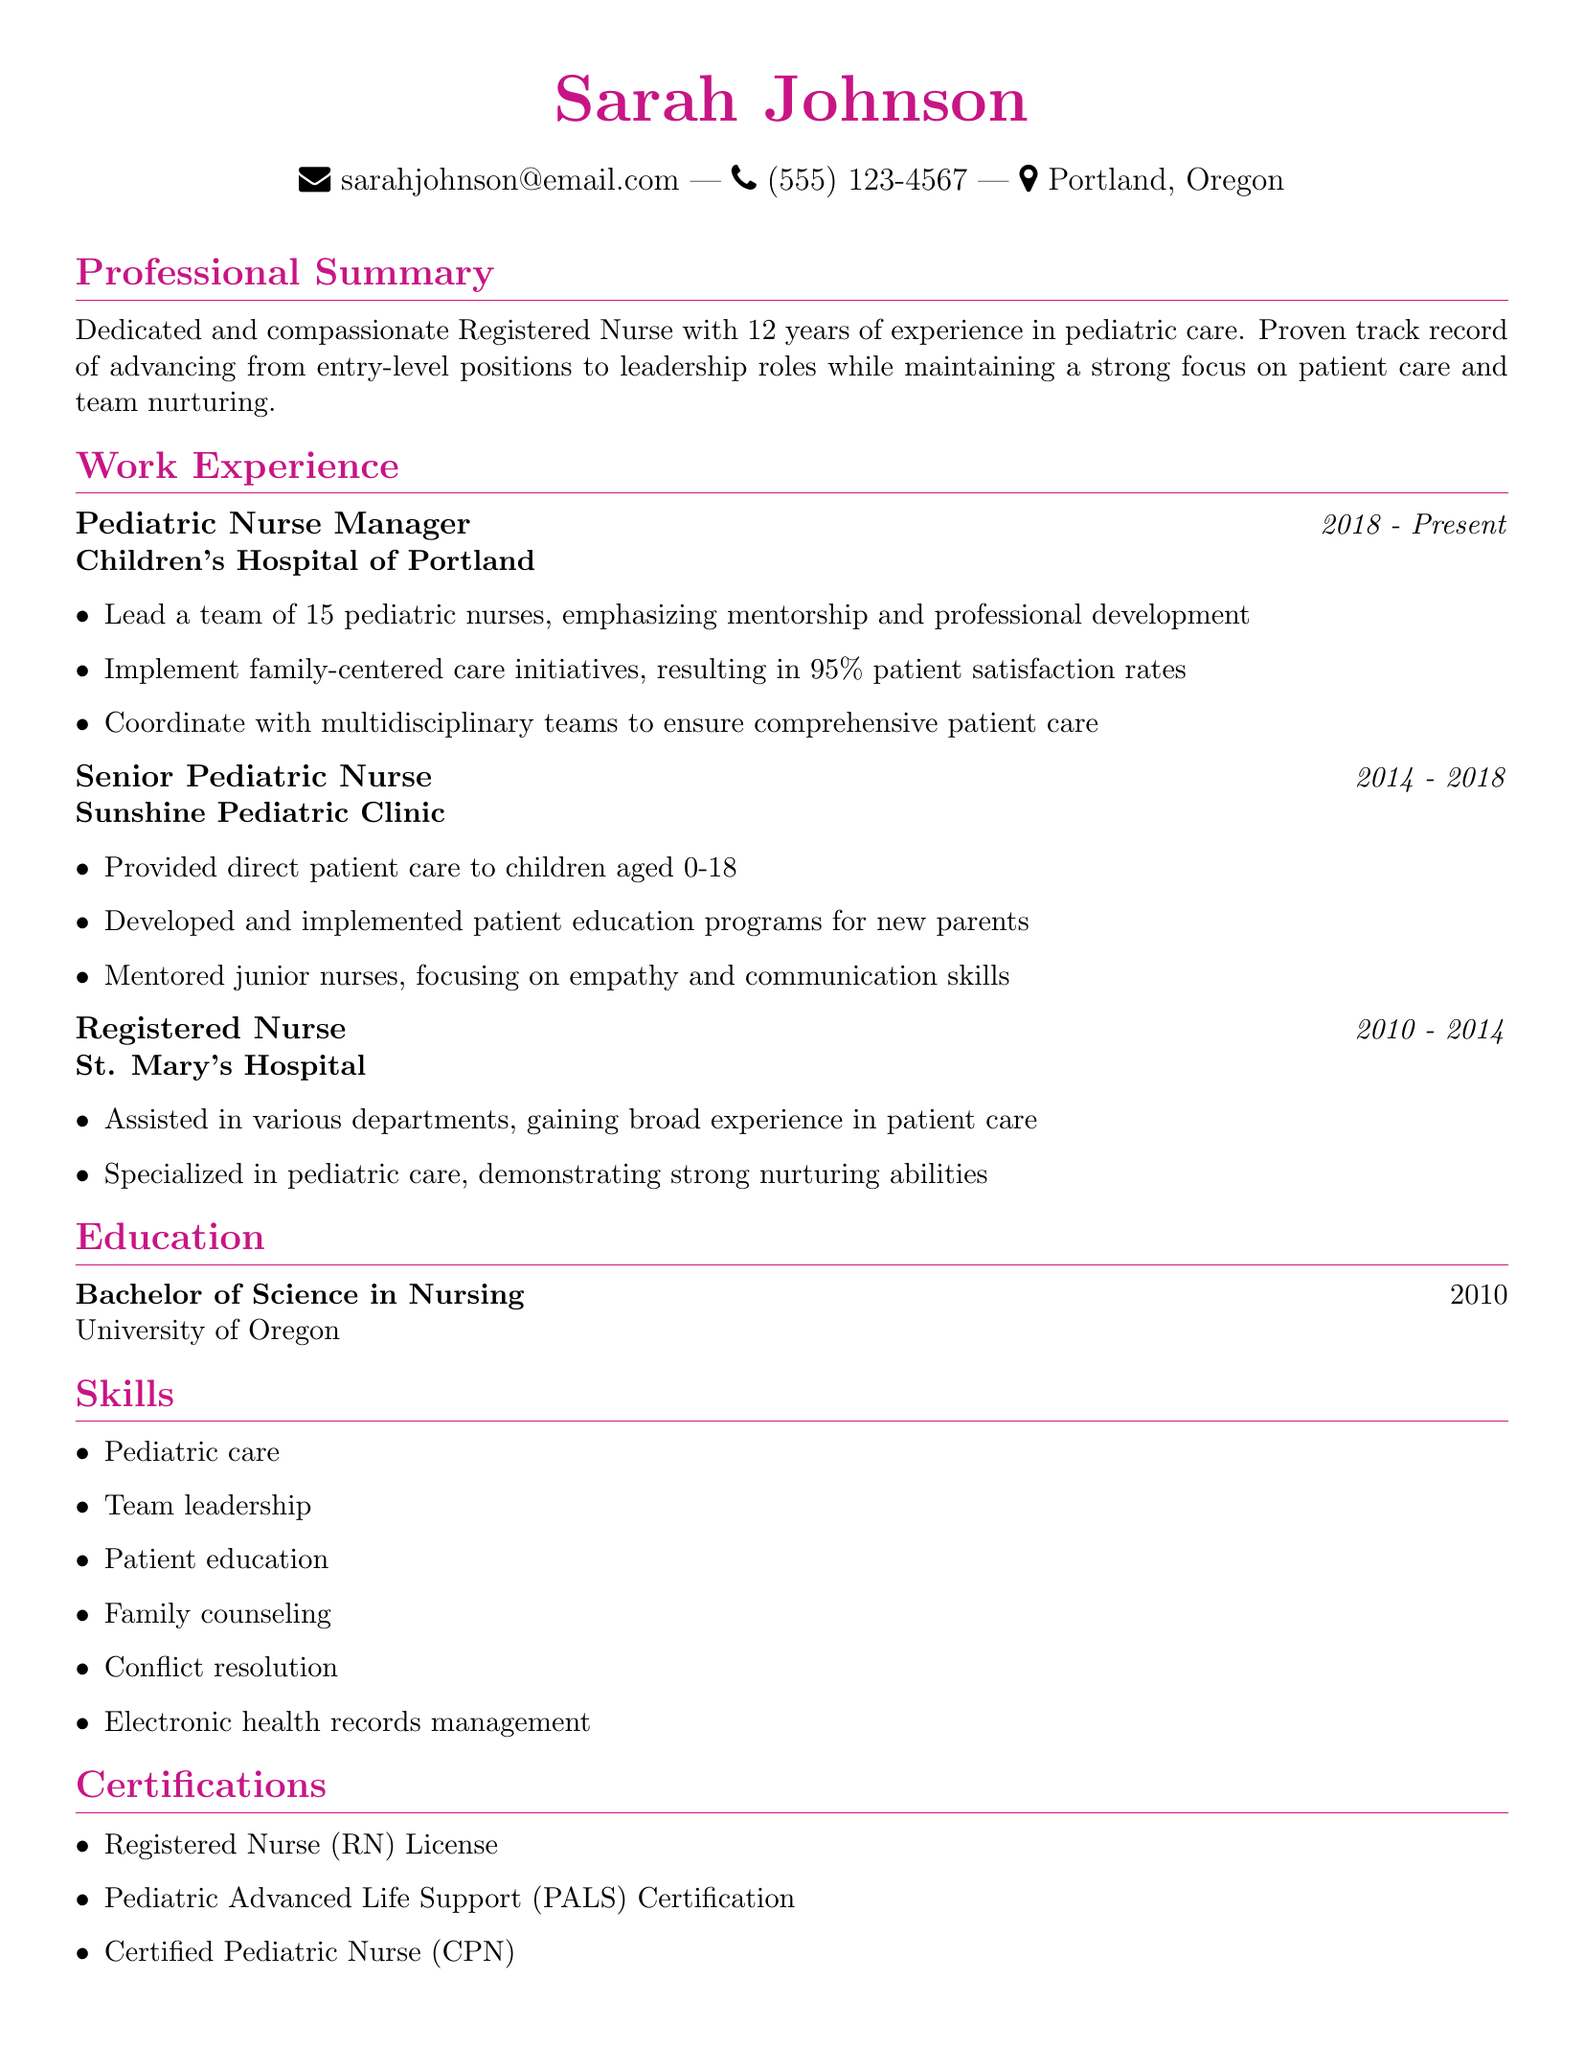What is Sarah Johnson's profession? The document states that Sarah Johnson is a Registered Nurse.
Answer: Registered Nurse How many years of experience does Sarah have? Sarah Johnson has 12 years of experience in pediatric care.
Answer: 12 years What is the title of Sarah's current position? The document specifies that her current position is Pediatric Nurse Manager.
Answer: Pediatric Nurse Manager In which city does Sarah reside? The document mentions that Sarah Johnson is located in Portland, Oregon.
Answer: Portland, Oregon What percentage of patient satisfaction did Sarah achieve? The document states that family-centered care initiatives resulted in 95% patient satisfaction rates.
Answer: 95% Which hospital did Sarah work at from 2010 to 2014? The document indicates that she worked at St. Mary's Hospital during that time.
Answer: St. Mary's Hospital What was one of the responsibilities of her role as Senior Pediatric Nurse? The document lists that she developed and implemented patient education programs for new parents.
Answer: Developed and implemented patient education programs How many nurses did Sarah manage in her current role? The document notes that she leads a team of 15 pediatric nurses.
Answer: 15 What degree does Sarah hold? The document states that she holds a Bachelor of Science in Nursing.
Answer: Bachelor of Science in Nursing What certification did Sarah obtain related to pediatric care? The document lists that she is a Certified Pediatric Nurse (CPN).
Answer: Certified Pediatric Nurse (CPN) 